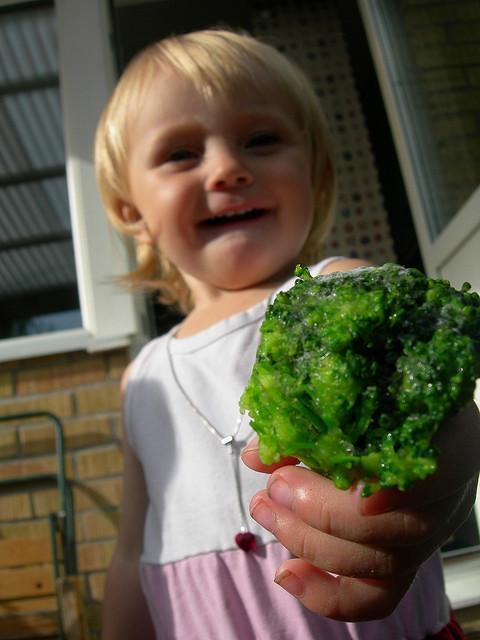Is the statement "The person is touching the broccoli." accurate regarding the image?
Answer yes or no. Yes. 